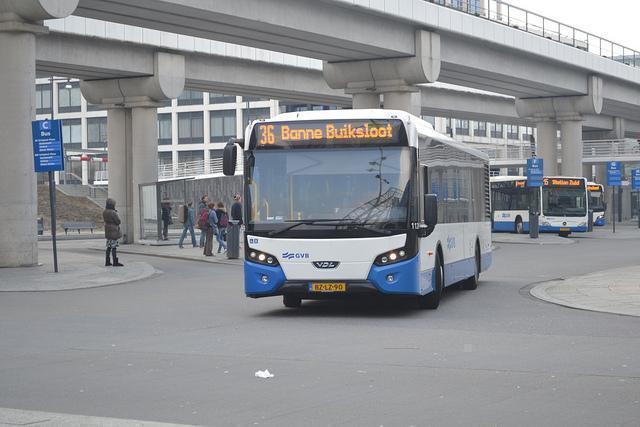Where are these people probably waiting to catch a bus?
Pick the correct solution from the four options below to address the question.
Options: Airport, street, terminal, underground. Terminal. 